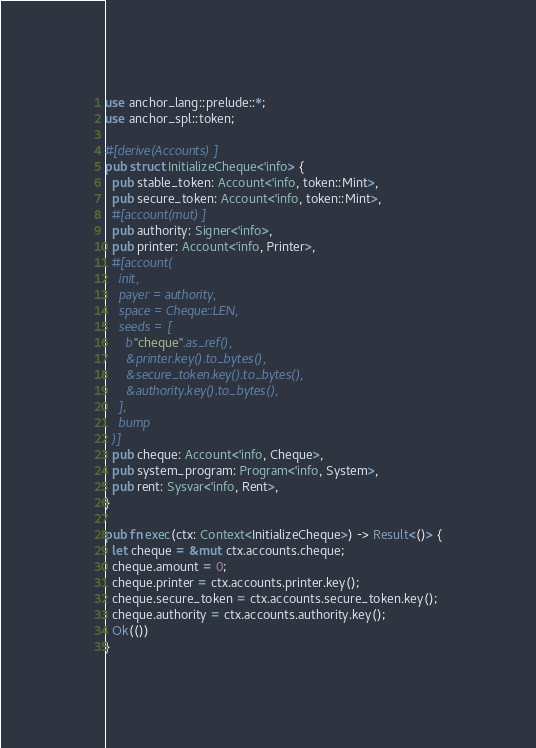<code> <loc_0><loc_0><loc_500><loc_500><_Rust_>use anchor_lang::prelude::*;
use anchor_spl::token;

#[derive(Accounts)]
pub struct InitializeCheque<'info> {
  pub stable_token: Account<'info, token::Mint>,
  pub secure_token: Account<'info, token::Mint>,
  #[account(mut)]
  pub authority: Signer<'info>,
  pub printer: Account<'info, Printer>,
  #[account(
    init,
    payer = authority,
    space = Cheque::LEN,
    seeds = [
      b"cheque".as_ref(),
      &printer.key().to_bytes(),
      &secure_token.key().to_bytes(),
      &authority.key().to_bytes(),
    ],
    bump
  )]
  pub cheque: Account<'info, Cheque>,
  pub system_program: Program<'info, System>,
  pub rent: Sysvar<'info, Rent>,
}

pub fn exec(ctx: Context<InitializeCheque>) -> Result<()> {
  let cheque = &mut ctx.accounts.cheque;
  cheque.amount = 0;
  cheque.printer = ctx.accounts.printer.key();
  cheque.secure_token = ctx.accounts.secure_token.key();
  cheque.authority = ctx.accounts.authority.key();
  Ok(())
}
</code> 